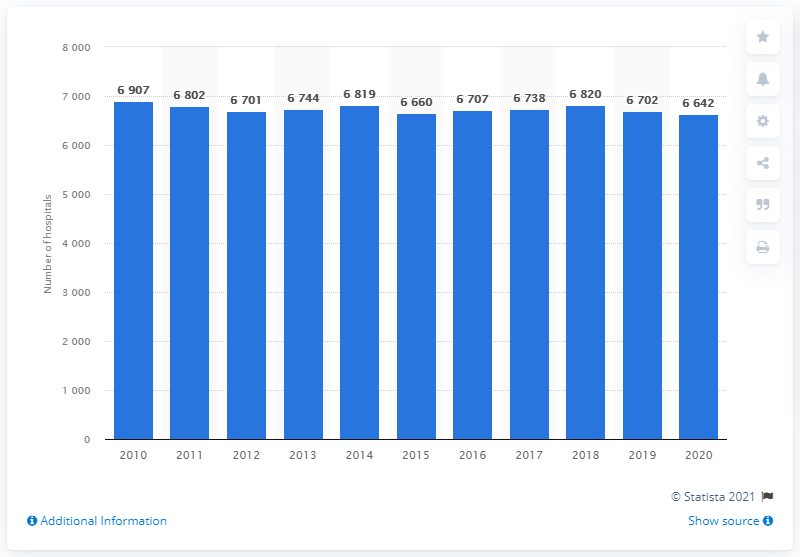Highlight a few significant elements in this photo. In 2010, the number of hospitals in Brazil reached its highest value. 